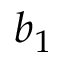Convert formula to latex. <formula><loc_0><loc_0><loc_500><loc_500>b _ { 1 }</formula> 